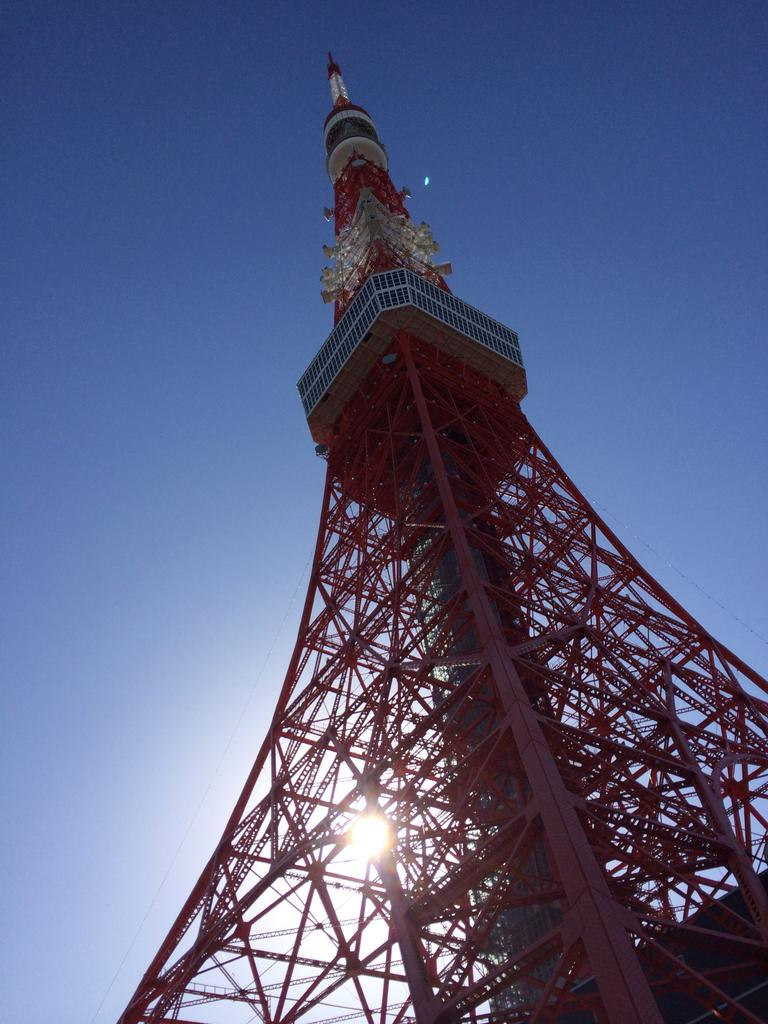What is the main structure in the image? There is a tower in the image. What material is used for the tower's construction? The tower has iron rods. Can you describe the background of the image? The sky is visible in the background of the image. How many items can be seen in the image? There are many items in the image. What type of insect can be seen attacking the tower in the image? There is no insect present in the image, nor is there any indication of an attack on the tower. 